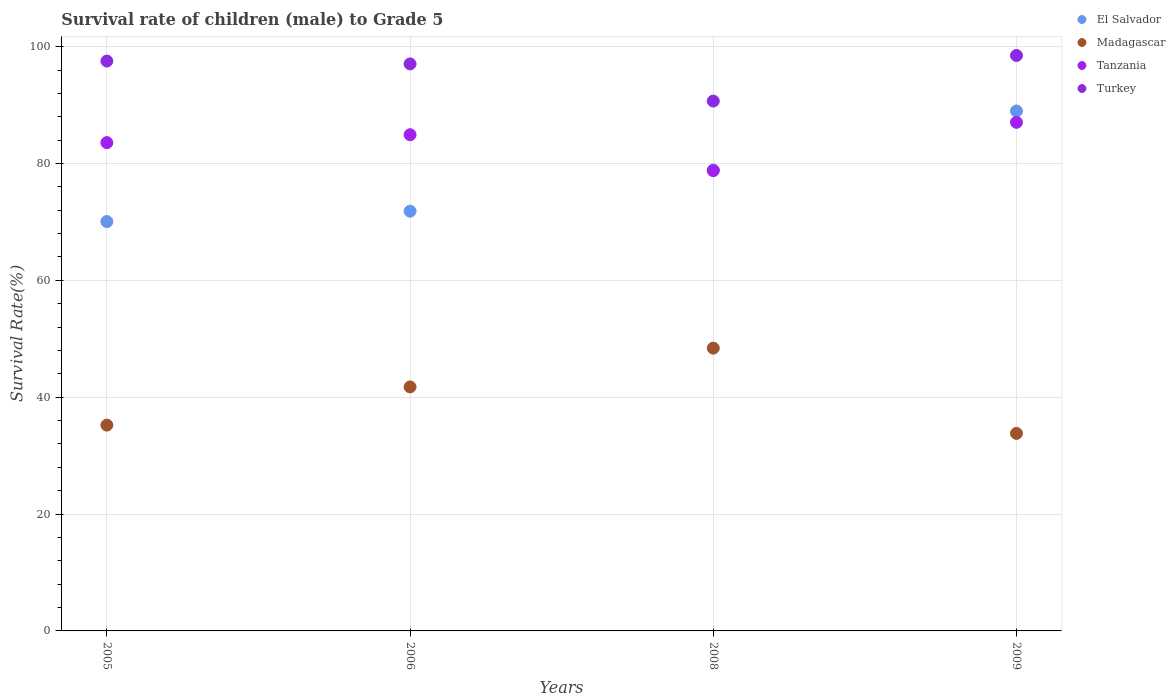Is the number of dotlines equal to the number of legend labels?
Offer a terse response. Yes. What is the survival rate of male children to grade 5 in Turkey in 2008?
Your answer should be compact. 90.68. Across all years, what is the maximum survival rate of male children to grade 5 in Madagascar?
Offer a terse response. 48.4. Across all years, what is the minimum survival rate of male children to grade 5 in Turkey?
Your answer should be very brief. 90.68. In which year was the survival rate of male children to grade 5 in Turkey maximum?
Make the answer very short. 2009. In which year was the survival rate of male children to grade 5 in Turkey minimum?
Provide a short and direct response. 2008. What is the total survival rate of male children to grade 5 in Tanzania in the graph?
Offer a terse response. 334.31. What is the difference between the survival rate of male children to grade 5 in El Salvador in 2006 and that in 2008?
Give a very brief answer. -7.04. What is the difference between the survival rate of male children to grade 5 in Madagascar in 2009 and the survival rate of male children to grade 5 in El Salvador in 2008?
Offer a very short reply. -45.07. What is the average survival rate of male children to grade 5 in Tanzania per year?
Make the answer very short. 83.58. In the year 2009, what is the difference between the survival rate of male children to grade 5 in Turkey and survival rate of male children to grade 5 in El Salvador?
Make the answer very short. 9.5. In how many years, is the survival rate of male children to grade 5 in El Salvador greater than 84 %?
Give a very brief answer. 1. What is the ratio of the survival rate of male children to grade 5 in Tanzania in 2008 to that in 2009?
Offer a very short reply. 0.91. Is the survival rate of male children to grade 5 in Turkey in 2005 less than that in 2006?
Your answer should be compact. No. Is the difference between the survival rate of male children to grade 5 in Turkey in 2005 and 2006 greater than the difference between the survival rate of male children to grade 5 in El Salvador in 2005 and 2006?
Give a very brief answer. Yes. What is the difference between the highest and the second highest survival rate of male children to grade 5 in El Salvador?
Give a very brief answer. 10.11. What is the difference between the highest and the lowest survival rate of male children to grade 5 in Madagascar?
Give a very brief answer. 14.6. In how many years, is the survival rate of male children to grade 5 in El Salvador greater than the average survival rate of male children to grade 5 in El Salvador taken over all years?
Provide a short and direct response. 2. Is the sum of the survival rate of male children to grade 5 in El Salvador in 2006 and 2008 greater than the maximum survival rate of male children to grade 5 in Madagascar across all years?
Provide a short and direct response. Yes. Is it the case that in every year, the sum of the survival rate of male children to grade 5 in Madagascar and survival rate of male children to grade 5 in Turkey  is greater than the sum of survival rate of male children to grade 5 in El Salvador and survival rate of male children to grade 5 in Tanzania?
Make the answer very short. No. Does the survival rate of male children to grade 5 in Madagascar monotonically increase over the years?
Provide a succinct answer. No. Is the survival rate of male children to grade 5 in Turkey strictly greater than the survival rate of male children to grade 5 in Madagascar over the years?
Offer a very short reply. Yes. How many dotlines are there?
Your answer should be very brief. 4. How many years are there in the graph?
Give a very brief answer. 4. What is the difference between two consecutive major ticks on the Y-axis?
Ensure brevity in your answer.  20. Are the values on the major ticks of Y-axis written in scientific E-notation?
Provide a succinct answer. No. How many legend labels are there?
Ensure brevity in your answer.  4. How are the legend labels stacked?
Ensure brevity in your answer.  Vertical. What is the title of the graph?
Give a very brief answer. Survival rate of children (male) to Grade 5. Does "Small states" appear as one of the legend labels in the graph?
Ensure brevity in your answer.  No. What is the label or title of the X-axis?
Keep it short and to the point. Years. What is the label or title of the Y-axis?
Ensure brevity in your answer.  Survival Rate(%). What is the Survival Rate(%) of El Salvador in 2005?
Your answer should be very brief. 70.06. What is the Survival Rate(%) in Madagascar in 2005?
Your answer should be compact. 35.23. What is the Survival Rate(%) in Tanzania in 2005?
Your answer should be compact. 83.57. What is the Survival Rate(%) in Turkey in 2005?
Your answer should be compact. 97.53. What is the Survival Rate(%) of El Salvador in 2006?
Keep it short and to the point. 71.84. What is the Survival Rate(%) of Madagascar in 2006?
Offer a very short reply. 41.76. What is the Survival Rate(%) in Tanzania in 2006?
Provide a succinct answer. 84.92. What is the Survival Rate(%) of Turkey in 2006?
Offer a very short reply. 97.04. What is the Survival Rate(%) of El Salvador in 2008?
Your response must be concise. 78.88. What is the Survival Rate(%) of Madagascar in 2008?
Your answer should be compact. 48.4. What is the Survival Rate(%) in Tanzania in 2008?
Offer a terse response. 78.78. What is the Survival Rate(%) of Turkey in 2008?
Keep it short and to the point. 90.68. What is the Survival Rate(%) of El Salvador in 2009?
Your response must be concise. 88.99. What is the Survival Rate(%) in Madagascar in 2009?
Provide a succinct answer. 33.8. What is the Survival Rate(%) in Tanzania in 2009?
Provide a succinct answer. 87.04. What is the Survival Rate(%) in Turkey in 2009?
Provide a succinct answer. 98.49. Across all years, what is the maximum Survival Rate(%) of El Salvador?
Make the answer very short. 88.99. Across all years, what is the maximum Survival Rate(%) in Madagascar?
Make the answer very short. 48.4. Across all years, what is the maximum Survival Rate(%) of Tanzania?
Make the answer very short. 87.04. Across all years, what is the maximum Survival Rate(%) in Turkey?
Offer a very short reply. 98.49. Across all years, what is the minimum Survival Rate(%) of El Salvador?
Provide a short and direct response. 70.06. Across all years, what is the minimum Survival Rate(%) of Madagascar?
Your response must be concise. 33.8. Across all years, what is the minimum Survival Rate(%) of Tanzania?
Keep it short and to the point. 78.78. Across all years, what is the minimum Survival Rate(%) of Turkey?
Offer a very short reply. 90.68. What is the total Survival Rate(%) in El Salvador in the graph?
Keep it short and to the point. 309.76. What is the total Survival Rate(%) of Madagascar in the graph?
Keep it short and to the point. 159.19. What is the total Survival Rate(%) in Tanzania in the graph?
Offer a terse response. 334.31. What is the total Survival Rate(%) of Turkey in the graph?
Your answer should be compact. 383.75. What is the difference between the Survival Rate(%) of El Salvador in 2005 and that in 2006?
Provide a succinct answer. -1.78. What is the difference between the Survival Rate(%) in Madagascar in 2005 and that in 2006?
Offer a terse response. -6.54. What is the difference between the Survival Rate(%) of Tanzania in 2005 and that in 2006?
Provide a short and direct response. -1.35. What is the difference between the Survival Rate(%) of Turkey in 2005 and that in 2006?
Keep it short and to the point. 0.49. What is the difference between the Survival Rate(%) in El Salvador in 2005 and that in 2008?
Your answer should be compact. -8.82. What is the difference between the Survival Rate(%) of Madagascar in 2005 and that in 2008?
Your answer should be compact. -13.18. What is the difference between the Survival Rate(%) in Tanzania in 2005 and that in 2008?
Your answer should be very brief. 4.79. What is the difference between the Survival Rate(%) in Turkey in 2005 and that in 2008?
Provide a short and direct response. 6.85. What is the difference between the Survival Rate(%) of El Salvador in 2005 and that in 2009?
Make the answer very short. -18.92. What is the difference between the Survival Rate(%) of Madagascar in 2005 and that in 2009?
Keep it short and to the point. 1.42. What is the difference between the Survival Rate(%) in Tanzania in 2005 and that in 2009?
Give a very brief answer. -3.48. What is the difference between the Survival Rate(%) of Turkey in 2005 and that in 2009?
Keep it short and to the point. -0.95. What is the difference between the Survival Rate(%) of El Salvador in 2006 and that in 2008?
Ensure brevity in your answer.  -7.04. What is the difference between the Survival Rate(%) of Madagascar in 2006 and that in 2008?
Your answer should be compact. -6.64. What is the difference between the Survival Rate(%) in Tanzania in 2006 and that in 2008?
Give a very brief answer. 6.15. What is the difference between the Survival Rate(%) in Turkey in 2006 and that in 2008?
Provide a succinct answer. 6.36. What is the difference between the Survival Rate(%) of El Salvador in 2006 and that in 2009?
Provide a succinct answer. -17.15. What is the difference between the Survival Rate(%) of Madagascar in 2006 and that in 2009?
Your answer should be very brief. 7.96. What is the difference between the Survival Rate(%) in Tanzania in 2006 and that in 2009?
Offer a very short reply. -2.12. What is the difference between the Survival Rate(%) of Turkey in 2006 and that in 2009?
Keep it short and to the point. -1.44. What is the difference between the Survival Rate(%) of El Salvador in 2008 and that in 2009?
Provide a short and direct response. -10.11. What is the difference between the Survival Rate(%) of Madagascar in 2008 and that in 2009?
Make the answer very short. 14.6. What is the difference between the Survival Rate(%) of Tanzania in 2008 and that in 2009?
Your answer should be very brief. -8.27. What is the difference between the Survival Rate(%) in Turkey in 2008 and that in 2009?
Your response must be concise. -7.8. What is the difference between the Survival Rate(%) in El Salvador in 2005 and the Survival Rate(%) in Madagascar in 2006?
Ensure brevity in your answer.  28.3. What is the difference between the Survival Rate(%) of El Salvador in 2005 and the Survival Rate(%) of Tanzania in 2006?
Provide a short and direct response. -14.86. What is the difference between the Survival Rate(%) in El Salvador in 2005 and the Survival Rate(%) in Turkey in 2006?
Give a very brief answer. -26.98. What is the difference between the Survival Rate(%) of Madagascar in 2005 and the Survival Rate(%) of Tanzania in 2006?
Ensure brevity in your answer.  -49.7. What is the difference between the Survival Rate(%) of Madagascar in 2005 and the Survival Rate(%) of Turkey in 2006?
Offer a terse response. -61.82. What is the difference between the Survival Rate(%) of Tanzania in 2005 and the Survival Rate(%) of Turkey in 2006?
Offer a terse response. -13.47. What is the difference between the Survival Rate(%) in El Salvador in 2005 and the Survival Rate(%) in Madagascar in 2008?
Ensure brevity in your answer.  21.66. What is the difference between the Survival Rate(%) of El Salvador in 2005 and the Survival Rate(%) of Tanzania in 2008?
Give a very brief answer. -8.72. What is the difference between the Survival Rate(%) of El Salvador in 2005 and the Survival Rate(%) of Turkey in 2008?
Your answer should be very brief. -20.62. What is the difference between the Survival Rate(%) in Madagascar in 2005 and the Survival Rate(%) in Tanzania in 2008?
Give a very brief answer. -43.55. What is the difference between the Survival Rate(%) of Madagascar in 2005 and the Survival Rate(%) of Turkey in 2008?
Make the answer very short. -55.46. What is the difference between the Survival Rate(%) in Tanzania in 2005 and the Survival Rate(%) in Turkey in 2008?
Make the answer very short. -7.12. What is the difference between the Survival Rate(%) in El Salvador in 2005 and the Survival Rate(%) in Madagascar in 2009?
Ensure brevity in your answer.  36.26. What is the difference between the Survival Rate(%) of El Salvador in 2005 and the Survival Rate(%) of Tanzania in 2009?
Keep it short and to the point. -16.98. What is the difference between the Survival Rate(%) in El Salvador in 2005 and the Survival Rate(%) in Turkey in 2009?
Provide a succinct answer. -28.43. What is the difference between the Survival Rate(%) in Madagascar in 2005 and the Survival Rate(%) in Tanzania in 2009?
Offer a very short reply. -51.82. What is the difference between the Survival Rate(%) in Madagascar in 2005 and the Survival Rate(%) in Turkey in 2009?
Offer a terse response. -63.26. What is the difference between the Survival Rate(%) of Tanzania in 2005 and the Survival Rate(%) of Turkey in 2009?
Your answer should be very brief. -14.92. What is the difference between the Survival Rate(%) in El Salvador in 2006 and the Survival Rate(%) in Madagascar in 2008?
Provide a short and direct response. 23.44. What is the difference between the Survival Rate(%) in El Salvador in 2006 and the Survival Rate(%) in Tanzania in 2008?
Make the answer very short. -6.94. What is the difference between the Survival Rate(%) of El Salvador in 2006 and the Survival Rate(%) of Turkey in 2008?
Offer a very short reply. -18.85. What is the difference between the Survival Rate(%) in Madagascar in 2006 and the Survival Rate(%) in Tanzania in 2008?
Ensure brevity in your answer.  -37.02. What is the difference between the Survival Rate(%) of Madagascar in 2006 and the Survival Rate(%) of Turkey in 2008?
Your answer should be very brief. -48.92. What is the difference between the Survival Rate(%) in Tanzania in 2006 and the Survival Rate(%) in Turkey in 2008?
Give a very brief answer. -5.76. What is the difference between the Survival Rate(%) of El Salvador in 2006 and the Survival Rate(%) of Madagascar in 2009?
Keep it short and to the point. 38.03. What is the difference between the Survival Rate(%) in El Salvador in 2006 and the Survival Rate(%) in Tanzania in 2009?
Make the answer very short. -15.21. What is the difference between the Survival Rate(%) in El Salvador in 2006 and the Survival Rate(%) in Turkey in 2009?
Offer a terse response. -26.65. What is the difference between the Survival Rate(%) of Madagascar in 2006 and the Survival Rate(%) of Tanzania in 2009?
Give a very brief answer. -45.28. What is the difference between the Survival Rate(%) in Madagascar in 2006 and the Survival Rate(%) in Turkey in 2009?
Make the answer very short. -56.73. What is the difference between the Survival Rate(%) in Tanzania in 2006 and the Survival Rate(%) in Turkey in 2009?
Your answer should be very brief. -13.56. What is the difference between the Survival Rate(%) of El Salvador in 2008 and the Survival Rate(%) of Madagascar in 2009?
Your answer should be very brief. 45.07. What is the difference between the Survival Rate(%) in El Salvador in 2008 and the Survival Rate(%) in Tanzania in 2009?
Provide a short and direct response. -8.17. What is the difference between the Survival Rate(%) of El Salvador in 2008 and the Survival Rate(%) of Turkey in 2009?
Offer a terse response. -19.61. What is the difference between the Survival Rate(%) in Madagascar in 2008 and the Survival Rate(%) in Tanzania in 2009?
Offer a very short reply. -38.64. What is the difference between the Survival Rate(%) in Madagascar in 2008 and the Survival Rate(%) in Turkey in 2009?
Your answer should be very brief. -50.09. What is the difference between the Survival Rate(%) of Tanzania in 2008 and the Survival Rate(%) of Turkey in 2009?
Your answer should be very brief. -19.71. What is the average Survival Rate(%) of El Salvador per year?
Make the answer very short. 77.44. What is the average Survival Rate(%) in Madagascar per year?
Offer a very short reply. 39.8. What is the average Survival Rate(%) of Tanzania per year?
Your answer should be compact. 83.58. What is the average Survival Rate(%) of Turkey per year?
Offer a very short reply. 95.94. In the year 2005, what is the difference between the Survival Rate(%) in El Salvador and Survival Rate(%) in Madagascar?
Give a very brief answer. 34.84. In the year 2005, what is the difference between the Survival Rate(%) of El Salvador and Survival Rate(%) of Tanzania?
Ensure brevity in your answer.  -13.51. In the year 2005, what is the difference between the Survival Rate(%) of El Salvador and Survival Rate(%) of Turkey?
Provide a succinct answer. -27.47. In the year 2005, what is the difference between the Survival Rate(%) of Madagascar and Survival Rate(%) of Tanzania?
Provide a succinct answer. -48.34. In the year 2005, what is the difference between the Survival Rate(%) in Madagascar and Survival Rate(%) in Turkey?
Your answer should be very brief. -62.31. In the year 2005, what is the difference between the Survival Rate(%) of Tanzania and Survival Rate(%) of Turkey?
Your answer should be compact. -13.96. In the year 2006, what is the difference between the Survival Rate(%) in El Salvador and Survival Rate(%) in Madagascar?
Keep it short and to the point. 30.08. In the year 2006, what is the difference between the Survival Rate(%) of El Salvador and Survival Rate(%) of Tanzania?
Provide a succinct answer. -13.09. In the year 2006, what is the difference between the Survival Rate(%) of El Salvador and Survival Rate(%) of Turkey?
Offer a terse response. -25.21. In the year 2006, what is the difference between the Survival Rate(%) of Madagascar and Survival Rate(%) of Tanzania?
Your response must be concise. -43.16. In the year 2006, what is the difference between the Survival Rate(%) in Madagascar and Survival Rate(%) in Turkey?
Give a very brief answer. -55.28. In the year 2006, what is the difference between the Survival Rate(%) in Tanzania and Survival Rate(%) in Turkey?
Your answer should be very brief. -12.12. In the year 2008, what is the difference between the Survival Rate(%) in El Salvador and Survival Rate(%) in Madagascar?
Give a very brief answer. 30.48. In the year 2008, what is the difference between the Survival Rate(%) in El Salvador and Survival Rate(%) in Tanzania?
Give a very brief answer. 0.1. In the year 2008, what is the difference between the Survival Rate(%) of El Salvador and Survival Rate(%) of Turkey?
Provide a short and direct response. -11.81. In the year 2008, what is the difference between the Survival Rate(%) of Madagascar and Survival Rate(%) of Tanzania?
Ensure brevity in your answer.  -30.38. In the year 2008, what is the difference between the Survival Rate(%) of Madagascar and Survival Rate(%) of Turkey?
Ensure brevity in your answer.  -42.28. In the year 2008, what is the difference between the Survival Rate(%) in Tanzania and Survival Rate(%) in Turkey?
Offer a very short reply. -11.91. In the year 2009, what is the difference between the Survival Rate(%) of El Salvador and Survival Rate(%) of Madagascar?
Keep it short and to the point. 55.18. In the year 2009, what is the difference between the Survival Rate(%) in El Salvador and Survival Rate(%) in Tanzania?
Provide a short and direct response. 1.94. In the year 2009, what is the difference between the Survival Rate(%) of El Salvador and Survival Rate(%) of Turkey?
Provide a succinct answer. -9.5. In the year 2009, what is the difference between the Survival Rate(%) in Madagascar and Survival Rate(%) in Tanzania?
Your response must be concise. -53.24. In the year 2009, what is the difference between the Survival Rate(%) of Madagascar and Survival Rate(%) of Turkey?
Your response must be concise. -64.68. In the year 2009, what is the difference between the Survival Rate(%) in Tanzania and Survival Rate(%) in Turkey?
Provide a short and direct response. -11.44. What is the ratio of the Survival Rate(%) in El Salvador in 2005 to that in 2006?
Your answer should be compact. 0.98. What is the ratio of the Survival Rate(%) in Madagascar in 2005 to that in 2006?
Your answer should be compact. 0.84. What is the ratio of the Survival Rate(%) of Turkey in 2005 to that in 2006?
Provide a succinct answer. 1. What is the ratio of the Survival Rate(%) in El Salvador in 2005 to that in 2008?
Keep it short and to the point. 0.89. What is the ratio of the Survival Rate(%) in Madagascar in 2005 to that in 2008?
Offer a very short reply. 0.73. What is the ratio of the Survival Rate(%) in Tanzania in 2005 to that in 2008?
Offer a terse response. 1.06. What is the ratio of the Survival Rate(%) in Turkey in 2005 to that in 2008?
Your response must be concise. 1.08. What is the ratio of the Survival Rate(%) in El Salvador in 2005 to that in 2009?
Keep it short and to the point. 0.79. What is the ratio of the Survival Rate(%) of Madagascar in 2005 to that in 2009?
Give a very brief answer. 1.04. What is the ratio of the Survival Rate(%) in Tanzania in 2005 to that in 2009?
Your answer should be compact. 0.96. What is the ratio of the Survival Rate(%) in Turkey in 2005 to that in 2009?
Provide a succinct answer. 0.99. What is the ratio of the Survival Rate(%) of El Salvador in 2006 to that in 2008?
Make the answer very short. 0.91. What is the ratio of the Survival Rate(%) of Madagascar in 2006 to that in 2008?
Ensure brevity in your answer.  0.86. What is the ratio of the Survival Rate(%) of Tanzania in 2006 to that in 2008?
Provide a short and direct response. 1.08. What is the ratio of the Survival Rate(%) in Turkey in 2006 to that in 2008?
Your response must be concise. 1.07. What is the ratio of the Survival Rate(%) in El Salvador in 2006 to that in 2009?
Ensure brevity in your answer.  0.81. What is the ratio of the Survival Rate(%) of Madagascar in 2006 to that in 2009?
Give a very brief answer. 1.24. What is the ratio of the Survival Rate(%) in Tanzania in 2006 to that in 2009?
Keep it short and to the point. 0.98. What is the ratio of the Survival Rate(%) of El Salvador in 2008 to that in 2009?
Provide a short and direct response. 0.89. What is the ratio of the Survival Rate(%) of Madagascar in 2008 to that in 2009?
Provide a short and direct response. 1.43. What is the ratio of the Survival Rate(%) in Tanzania in 2008 to that in 2009?
Ensure brevity in your answer.  0.91. What is the ratio of the Survival Rate(%) in Turkey in 2008 to that in 2009?
Make the answer very short. 0.92. What is the difference between the highest and the second highest Survival Rate(%) in El Salvador?
Offer a very short reply. 10.11. What is the difference between the highest and the second highest Survival Rate(%) of Madagascar?
Offer a terse response. 6.64. What is the difference between the highest and the second highest Survival Rate(%) of Tanzania?
Ensure brevity in your answer.  2.12. What is the difference between the highest and the second highest Survival Rate(%) in Turkey?
Offer a very short reply. 0.95. What is the difference between the highest and the lowest Survival Rate(%) of El Salvador?
Offer a terse response. 18.92. What is the difference between the highest and the lowest Survival Rate(%) of Madagascar?
Keep it short and to the point. 14.6. What is the difference between the highest and the lowest Survival Rate(%) of Tanzania?
Your answer should be very brief. 8.27. What is the difference between the highest and the lowest Survival Rate(%) of Turkey?
Offer a very short reply. 7.8. 